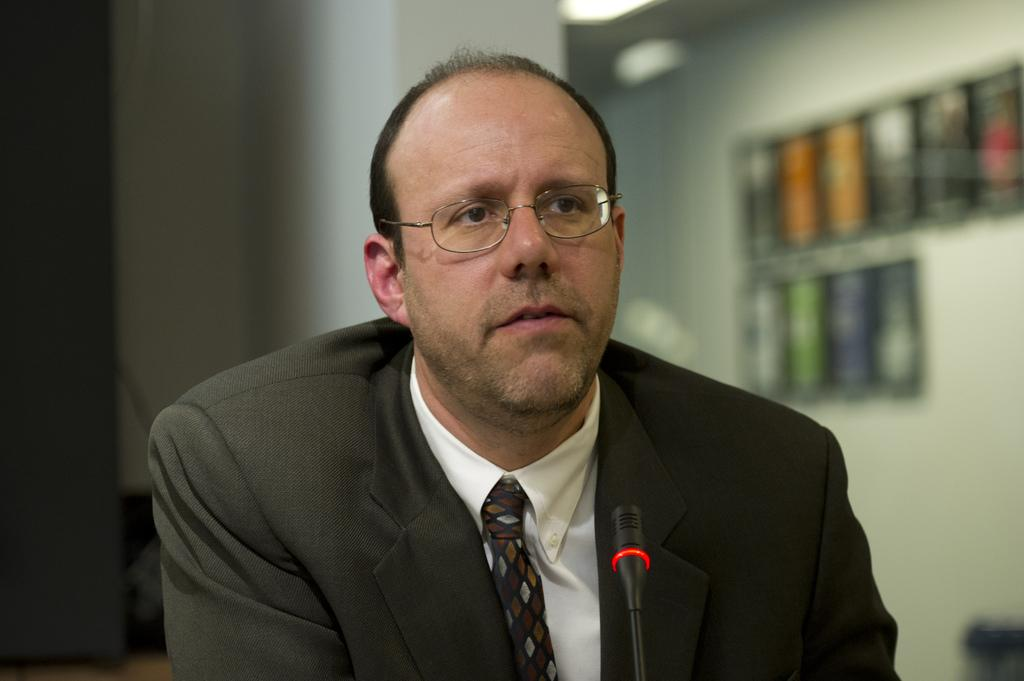Who is the main subject in the image? There is a man in the middle of the image. What is the man wearing? The man is wearing a suit, a shirt, and a tie. What object is in front of the man? There is a microphone in front of the man. What can be seen in the background of the image? There are photo frames, lights, and a wall in the background. What is the rate of the cherry tree's growth in the image? There is no cherry tree present in the image, so it is not possible to determine its growth rate. What religion is the man practicing in the image? There is no indication of the man's religion in the image, as it only shows him wearing a suit, a shirt, and a tie, and standing in front of a microphone. 